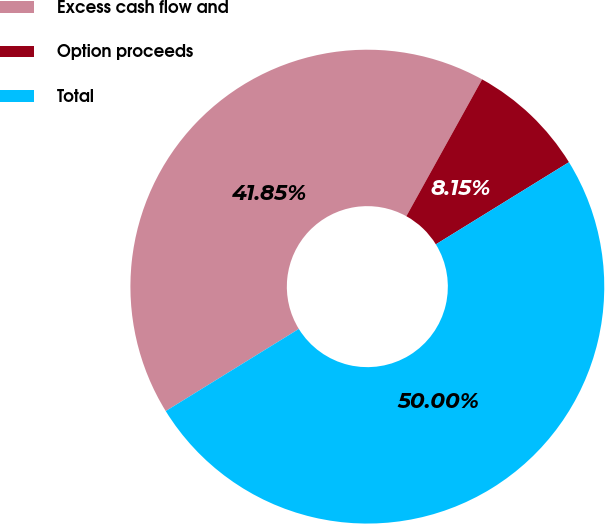Convert chart. <chart><loc_0><loc_0><loc_500><loc_500><pie_chart><fcel>Excess cash flow and<fcel>Option proceeds<fcel>Total<nl><fcel>41.85%<fcel>8.15%<fcel>50.0%<nl></chart> 